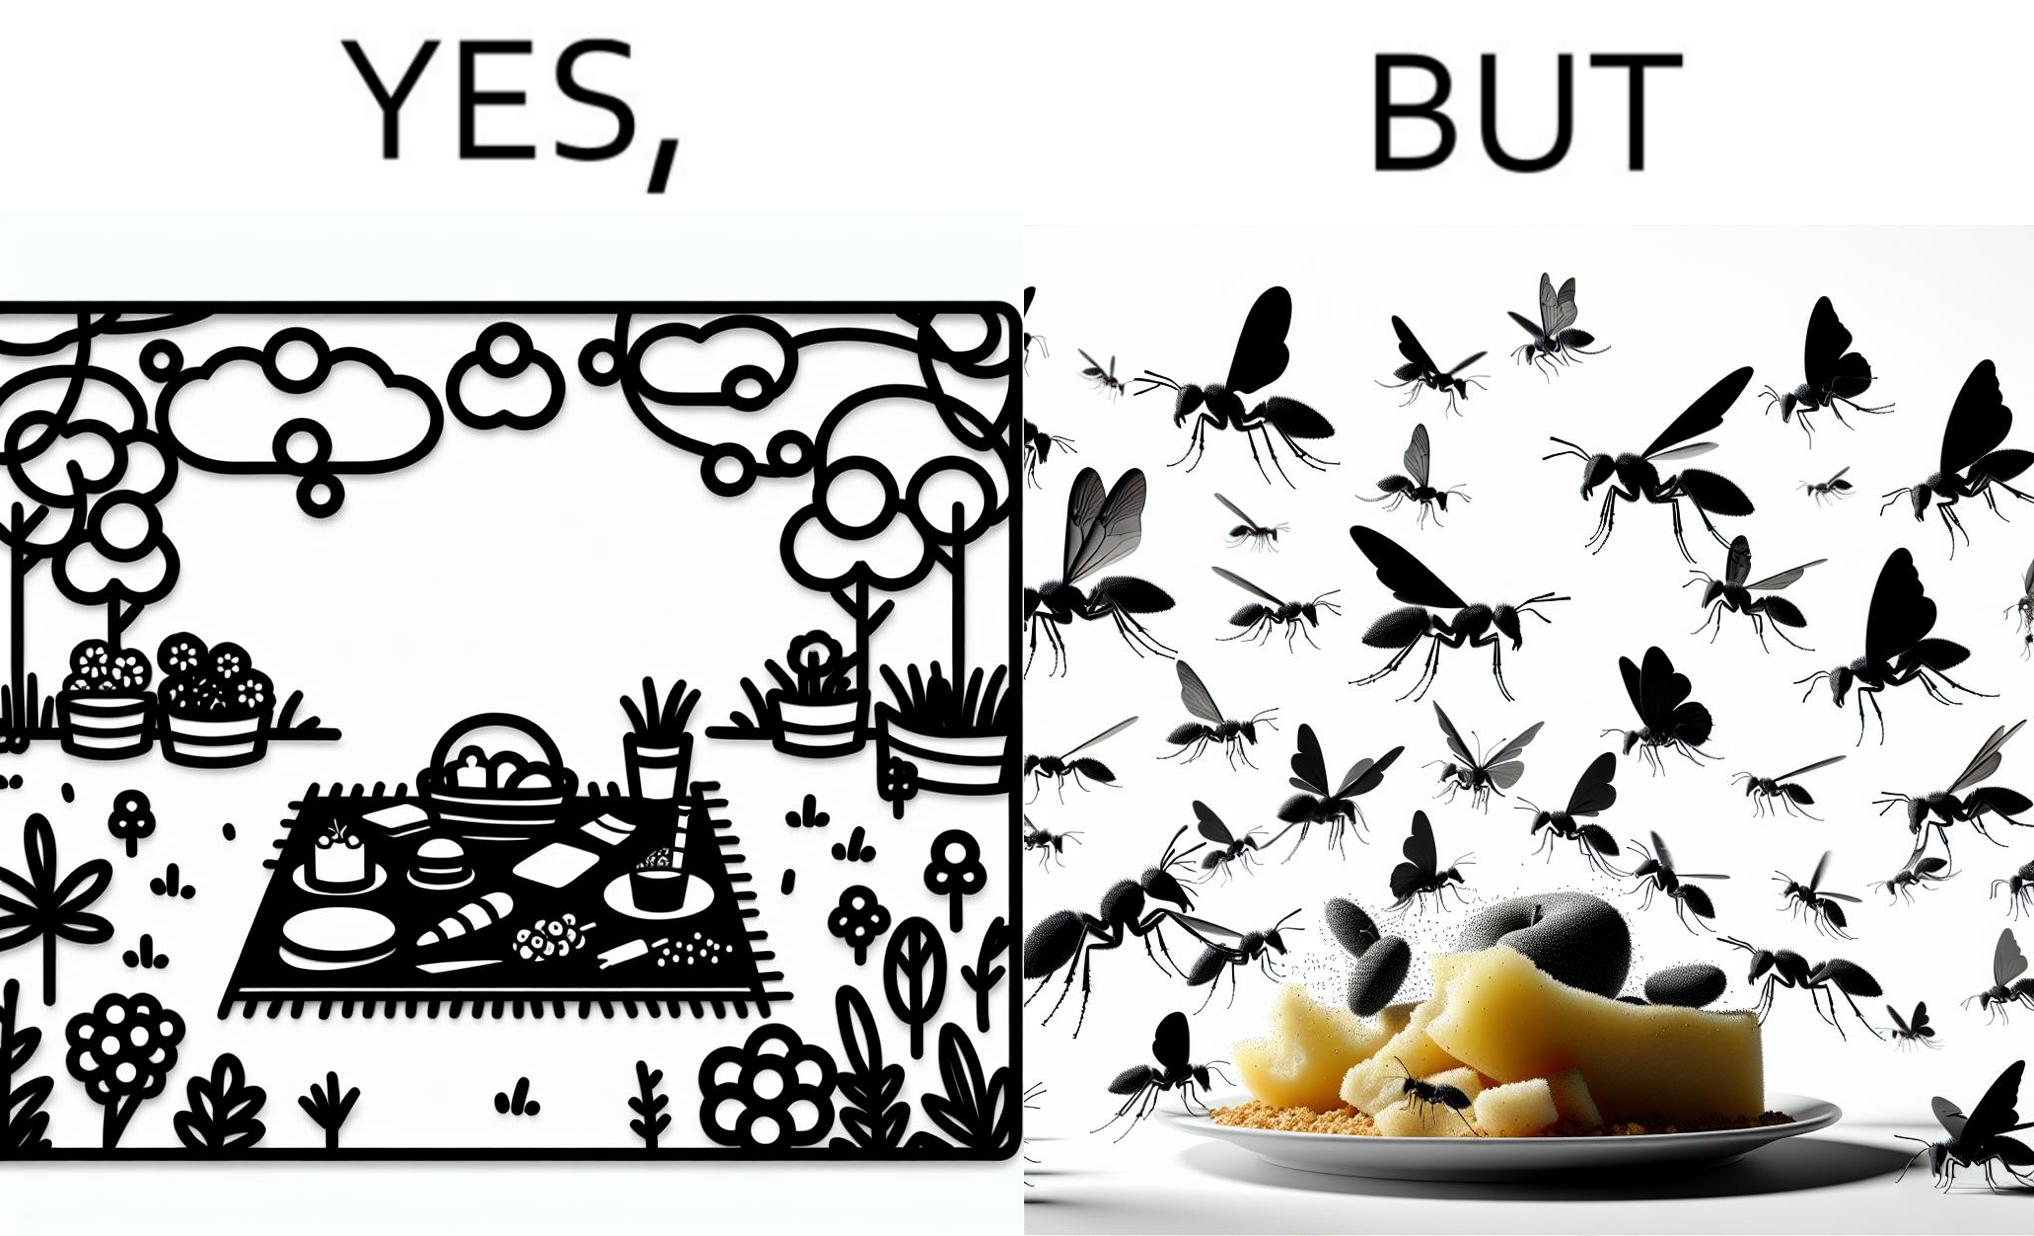Compare the left and right sides of this image. In the left part of the image: The food is kept on a blanket in a garden. In the right part of the image: Some bugs are attracting towards the food. 